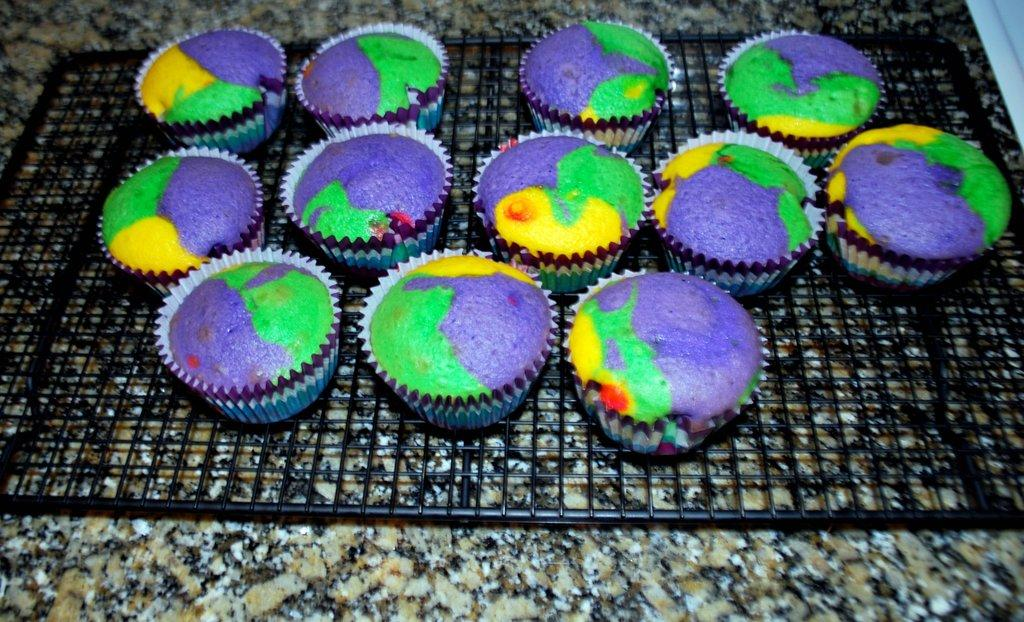What type of dessert is on the stand in the image? There are cupcakes on a stand in the image. What color is the stand holding the cupcakes? The stand is black in color. What material is the floor made of in the image? The floor appears to be made of granite. What can be seen in the top right corner of the image? There is a white-colored wooden wall in the top right corner of the image. Are there any curtains hanging from the white-colored wooden wall in the image? There are no curtains visible in the image; only the white-colored wooden wall is present. 